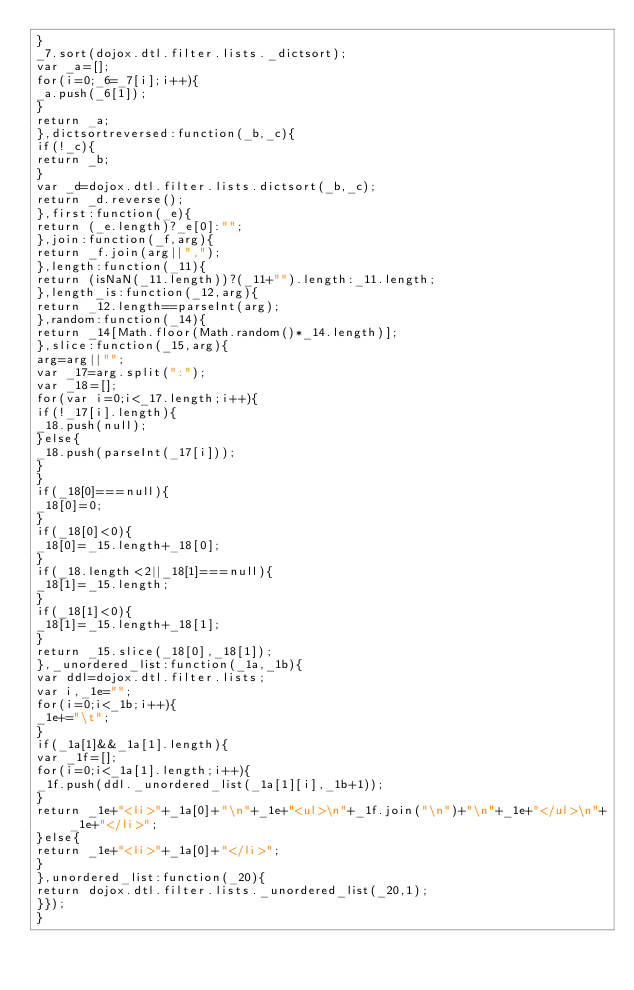Convert code to text. <code><loc_0><loc_0><loc_500><loc_500><_JavaScript_>}
_7.sort(dojox.dtl.filter.lists._dictsort);
var _a=[];
for(i=0;_6=_7[i];i++){
_a.push(_6[1]);
}
return _a;
},dictsortreversed:function(_b,_c){
if(!_c){
return _b;
}
var _d=dojox.dtl.filter.lists.dictsort(_b,_c);
return _d.reverse();
},first:function(_e){
return (_e.length)?_e[0]:"";
},join:function(_f,arg){
return _f.join(arg||",");
},length:function(_11){
return (isNaN(_11.length))?(_11+"").length:_11.length;
},length_is:function(_12,arg){
return _12.length==parseInt(arg);
},random:function(_14){
return _14[Math.floor(Math.random()*_14.length)];
},slice:function(_15,arg){
arg=arg||"";
var _17=arg.split(":");
var _18=[];
for(var i=0;i<_17.length;i++){
if(!_17[i].length){
_18.push(null);
}else{
_18.push(parseInt(_17[i]));
}
}
if(_18[0]===null){
_18[0]=0;
}
if(_18[0]<0){
_18[0]=_15.length+_18[0];
}
if(_18.length<2||_18[1]===null){
_18[1]=_15.length;
}
if(_18[1]<0){
_18[1]=_15.length+_18[1];
}
return _15.slice(_18[0],_18[1]);
},_unordered_list:function(_1a,_1b){
var ddl=dojox.dtl.filter.lists;
var i,_1e="";
for(i=0;i<_1b;i++){
_1e+="\t";
}
if(_1a[1]&&_1a[1].length){
var _1f=[];
for(i=0;i<_1a[1].length;i++){
_1f.push(ddl._unordered_list(_1a[1][i],_1b+1));
}
return _1e+"<li>"+_1a[0]+"\n"+_1e+"<ul>\n"+_1f.join("\n")+"\n"+_1e+"</ul>\n"+_1e+"</li>";
}else{
return _1e+"<li>"+_1a[0]+"</li>";
}
},unordered_list:function(_20){
return dojox.dtl.filter.lists._unordered_list(_20,1);
}});
}
</code> 